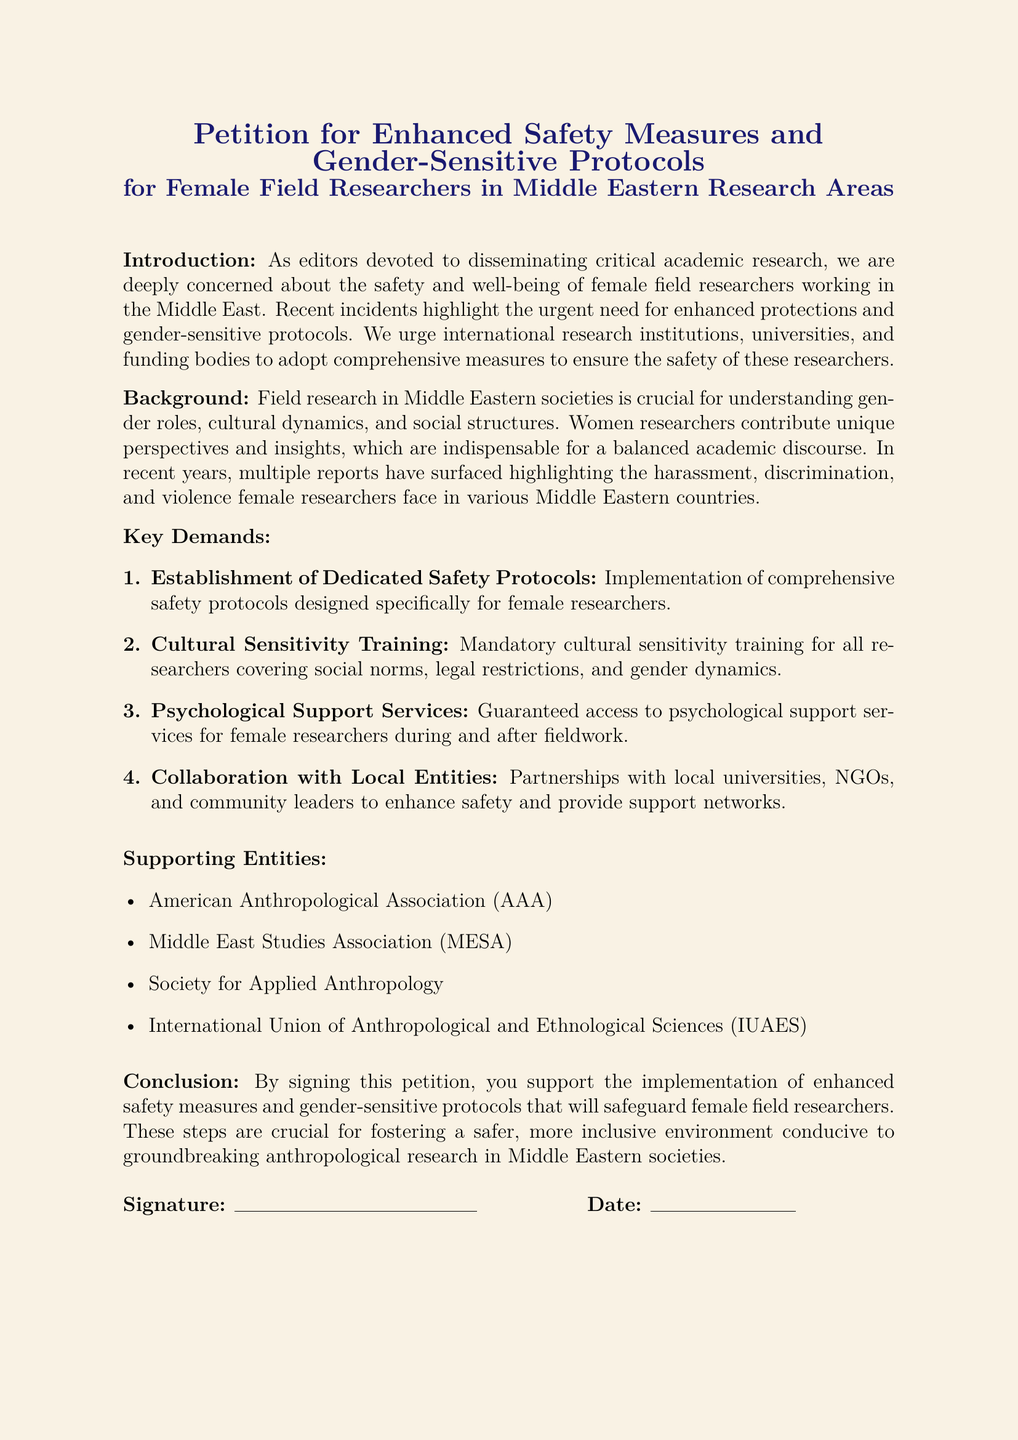What is the purpose of this petition? The purpose of the petition is to urge for enhanced safety measures and gender-sensitive protocols for female field researchers in Middle Eastern research areas.
Answer: Enhanced safety measures and gender-sensitive protocols Who are the supporting entities listed in the petition? The petition lists several organizations that support its cause, including the American Anthropological Association and Middle East Studies Association.
Answer: American Anthropological Association, Middle East Studies Association, Society for Applied Anthropology, International Union of Anthropological and Ethnological Sciences What is one of the key demands of the petition? The document outlines specific demands, including the implementation of comprehensive safety protocols designed specifically for female researchers.
Answer: Establishment of Dedicated Safety Protocols How many key demands are there in total? The document enumerates the key demands listed in the petition, confirming the total number of demands.
Answer: Four What is provided as a method of psychological support in the petition? The petition emphasizes guaranteed access to psychological support services for female researchers as part of its demands.
Answer: Psychological Support Services What color is the page background of the document? The document specifies a color used for the page background, which is visually distinctive in the rendered document.
Answer: Sandstone What type of training is mandatory according to the petition? The petition specifies a type of training that is mandated for researchers, focusing on cultural awareness.
Answer: Cultural Sensitivity Training What is the signature line length provided in the document? The document specifies the length of the signature line which indicates how much space is allocated for signatures.
Answer: 5 cm What is the date line length provided in the document? The document specifies the length of the date line which indicates how much space is allocated for writing the date.
Answer: 3 cm 